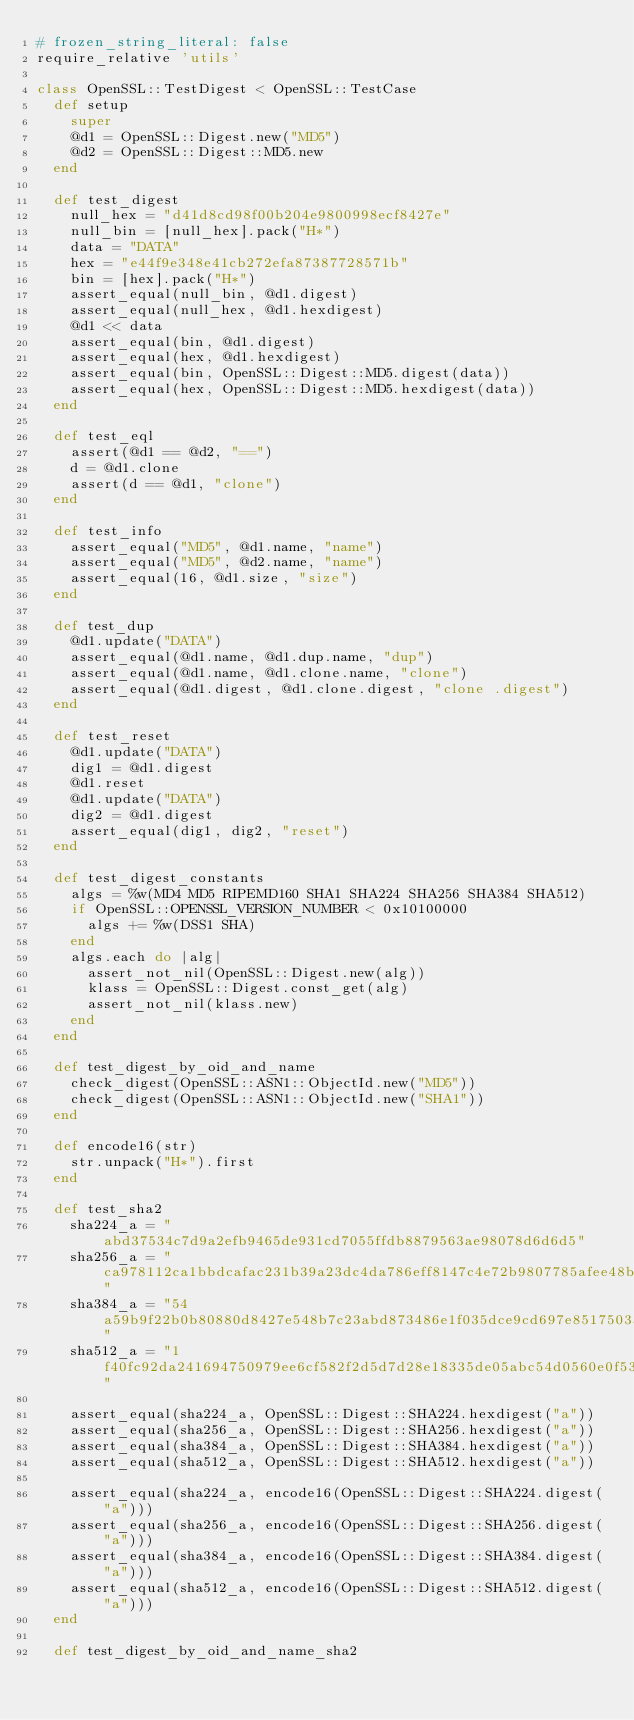<code> <loc_0><loc_0><loc_500><loc_500><_Ruby_># frozen_string_literal: false
require_relative 'utils'

class OpenSSL::TestDigest < OpenSSL::TestCase
  def setup
    super
    @d1 = OpenSSL::Digest.new("MD5")
    @d2 = OpenSSL::Digest::MD5.new
  end

  def test_digest
    null_hex = "d41d8cd98f00b204e9800998ecf8427e"
    null_bin = [null_hex].pack("H*")
    data = "DATA"
    hex = "e44f9e348e41cb272efa87387728571b"
    bin = [hex].pack("H*")
    assert_equal(null_bin, @d1.digest)
    assert_equal(null_hex, @d1.hexdigest)
    @d1 << data
    assert_equal(bin, @d1.digest)
    assert_equal(hex, @d1.hexdigest)
    assert_equal(bin, OpenSSL::Digest::MD5.digest(data))
    assert_equal(hex, OpenSSL::Digest::MD5.hexdigest(data))
  end

  def test_eql
    assert(@d1 == @d2, "==")
    d = @d1.clone
    assert(d == @d1, "clone")
  end

  def test_info
    assert_equal("MD5", @d1.name, "name")
    assert_equal("MD5", @d2.name, "name")
    assert_equal(16, @d1.size, "size")
  end

  def test_dup
    @d1.update("DATA")
    assert_equal(@d1.name, @d1.dup.name, "dup")
    assert_equal(@d1.name, @d1.clone.name, "clone")
    assert_equal(@d1.digest, @d1.clone.digest, "clone .digest")
  end

  def test_reset
    @d1.update("DATA")
    dig1 = @d1.digest
    @d1.reset
    @d1.update("DATA")
    dig2 = @d1.digest
    assert_equal(dig1, dig2, "reset")
  end

  def test_digest_constants
    algs = %w(MD4 MD5 RIPEMD160 SHA1 SHA224 SHA256 SHA384 SHA512)
    if OpenSSL::OPENSSL_VERSION_NUMBER < 0x10100000
      algs += %w(DSS1 SHA)
    end
    algs.each do |alg|
      assert_not_nil(OpenSSL::Digest.new(alg))
      klass = OpenSSL::Digest.const_get(alg)
      assert_not_nil(klass.new)
    end
  end

  def test_digest_by_oid_and_name
    check_digest(OpenSSL::ASN1::ObjectId.new("MD5"))
    check_digest(OpenSSL::ASN1::ObjectId.new("SHA1"))
  end

  def encode16(str)
    str.unpack("H*").first
  end

  def test_sha2
    sha224_a = "abd37534c7d9a2efb9465de931cd7055ffdb8879563ae98078d6d6d5"
    sha256_a = "ca978112ca1bbdcafac231b39a23dc4da786eff8147c4e72b9807785afee48bb"
    sha384_a = "54a59b9f22b0b80880d8427e548b7c23abd873486e1f035dce9cd697e85175033caa88e6d57bc35efae0b5afd3145f31"
    sha512_a = "1f40fc92da241694750979ee6cf582f2d5d7d28e18335de05abc54d0560e0f5302860c652bf08d560252aa5e74210546f369fbbbce8c12cfc7957b2652fe9a75"

    assert_equal(sha224_a, OpenSSL::Digest::SHA224.hexdigest("a"))
    assert_equal(sha256_a, OpenSSL::Digest::SHA256.hexdigest("a"))
    assert_equal(sha384_a, OpenSSL::Digest::SHA384.hexdigest("a"))
    assert_equal(sha512_a, OpenSSL::Digest::SHA512.hexdigest("a"))

    assert_equal(sha224_a, encode16(OpenSSL::Digest::SHA224.digest("a")))
    assert_equal(sha256_a, encode16(OpenSSL::Digest::SHA256.digest("a")))
    assert_equal(sha384_a, encode16(OpenSSL::Digest::SHA384.digest("a")))
    assert_equal(sha512_a, encode16(OpenSSL::Digest::SHA512.digest("a")))
  end

  def test_digest_by_oid_and_name_sha2</code> 